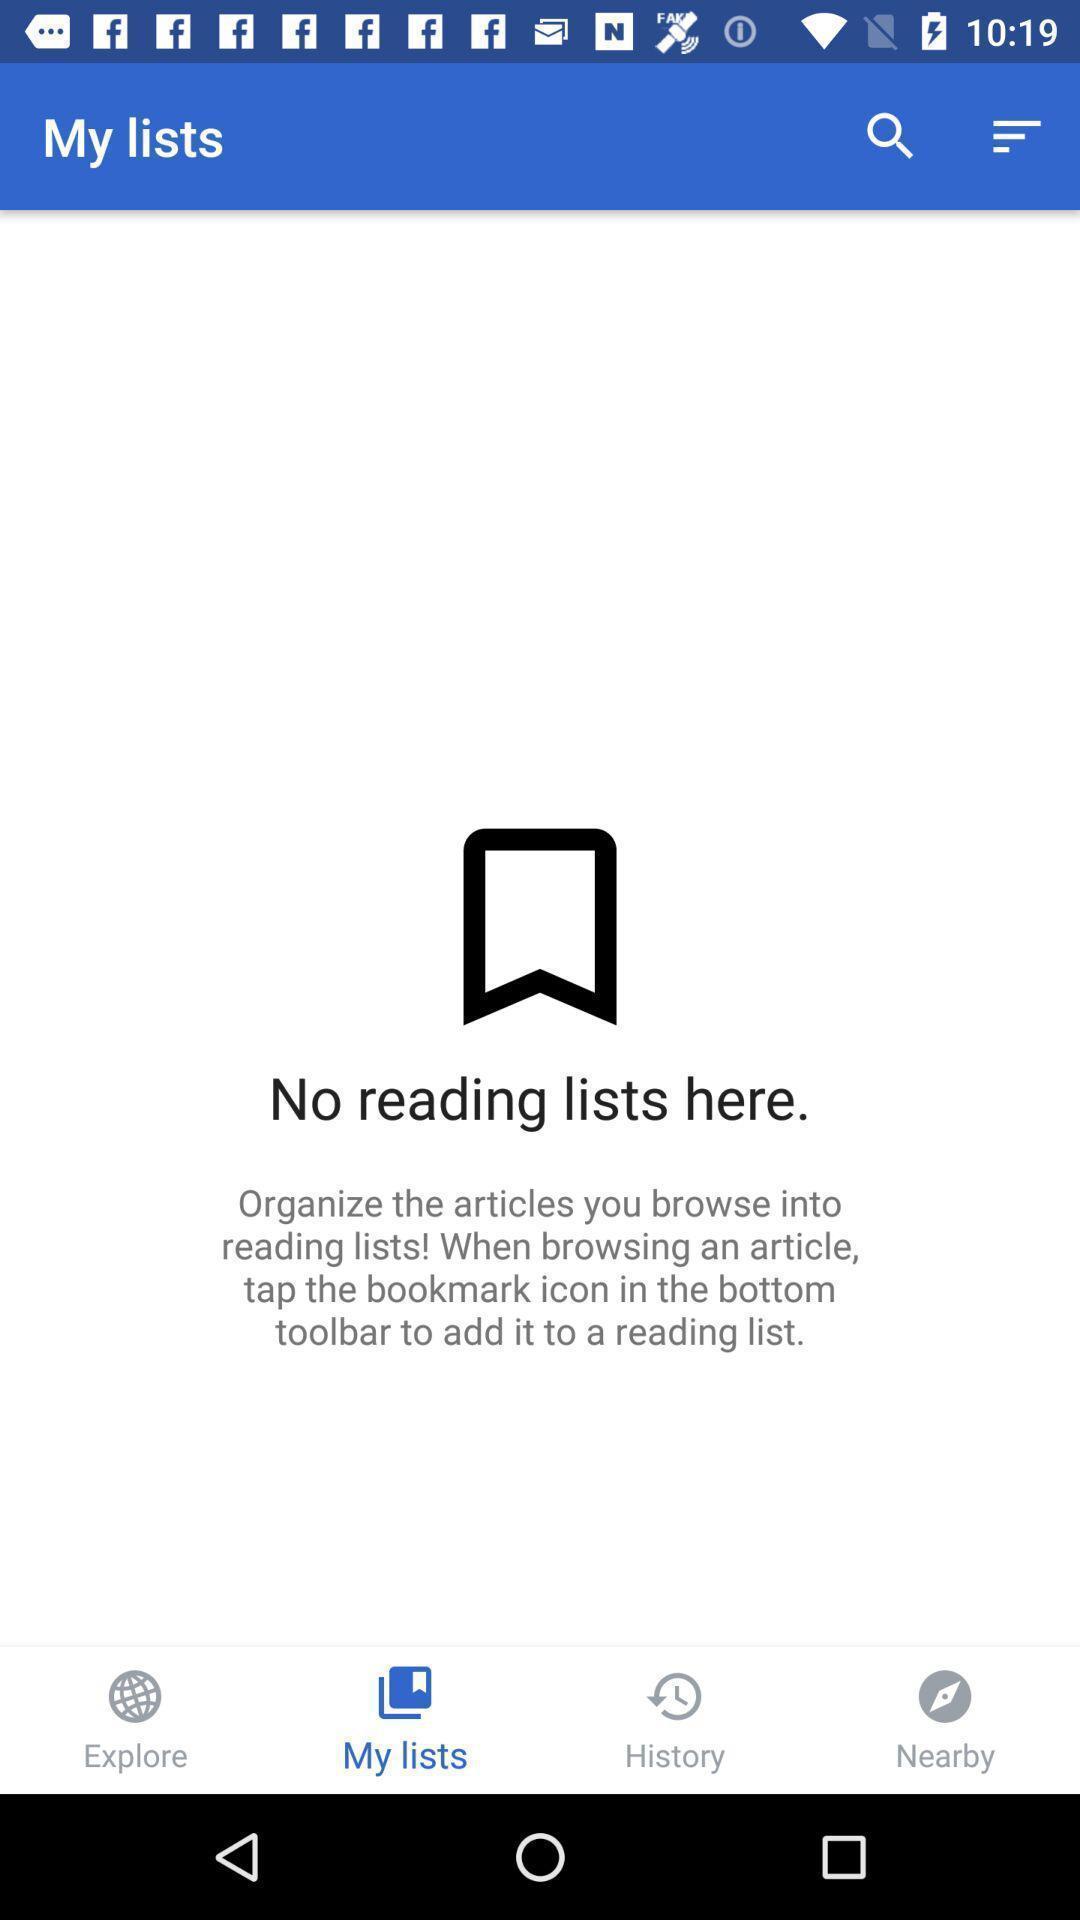Please provide a description for this image. Screen displaying the my lists page. 